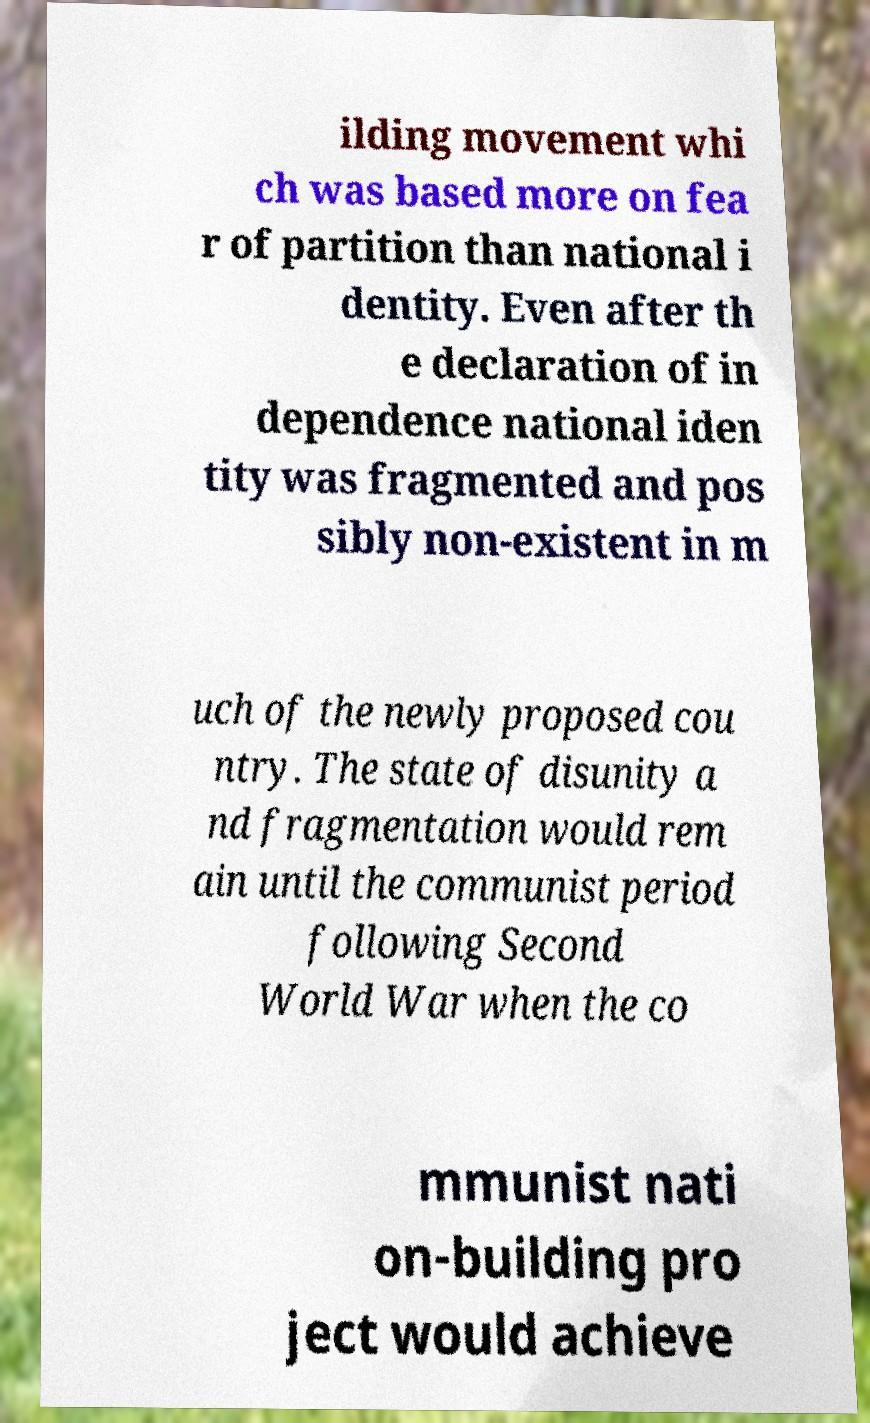There's text embedded in this image that I need extracted. Can you transcribe it verbatim? ilding movement whi ch was based more on fea r of partition than national i dentity. Even after th e declaration of in dependence national iden tity was fragmented and pos sibly non-existent in m uch of the newly proposed cou ntry. The state of disunity a nd fragmentation would rem ain until the communist period following Second World War when the co mmunist nati on-building pro ject would achieve 